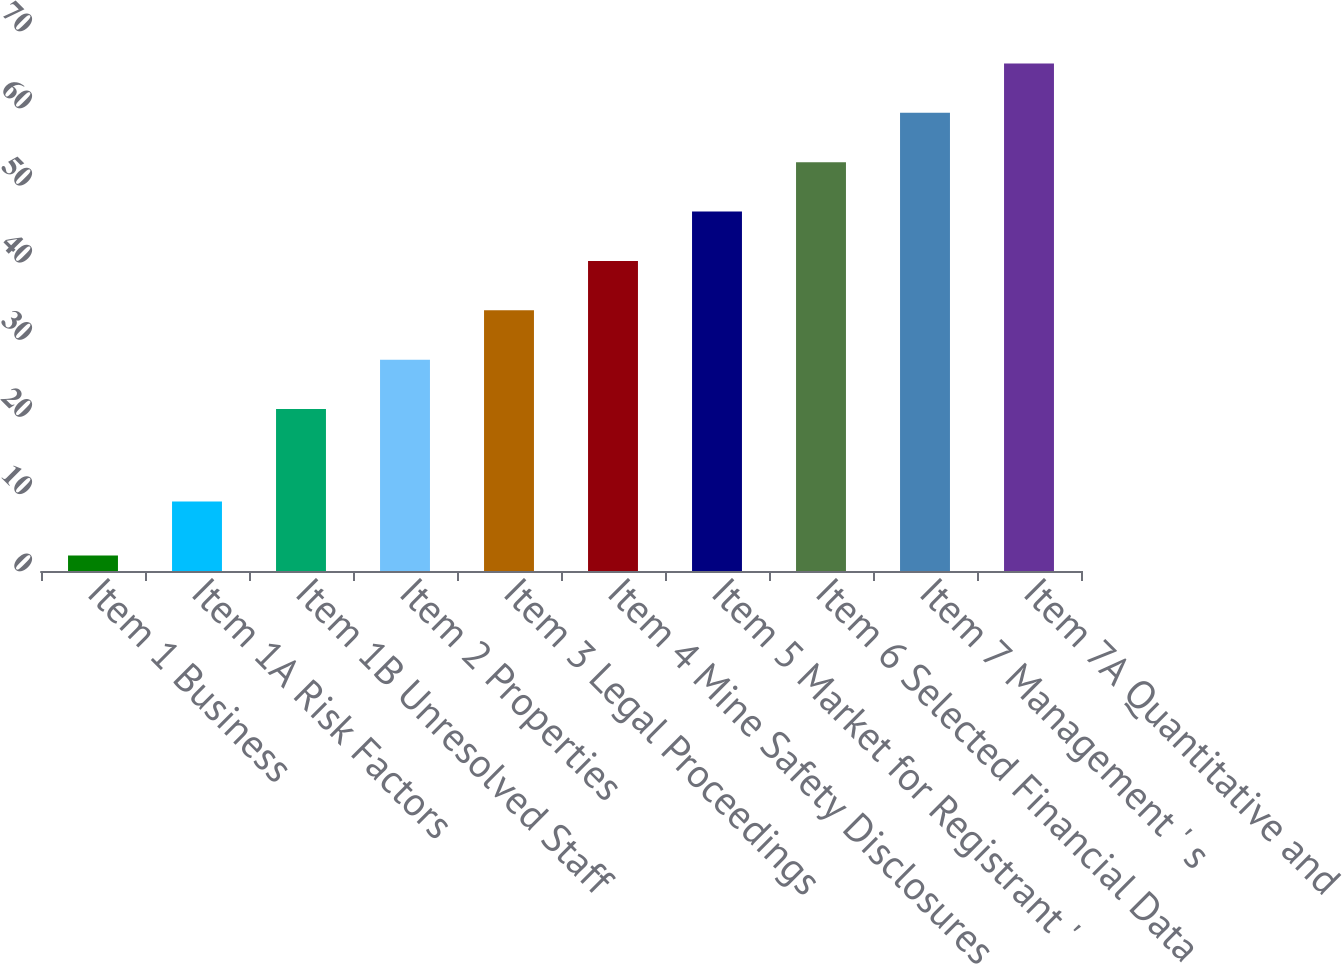Convert chart. <chart><loc_0><loc_0><loc_500><loc_500><bar_chart><fcel>Item 1 Business<fcel>Item 1A Risk Factors<fcel>Item 1B Unresolved Staff<fcel>Item 2 Properties<fcel>Item 3 Legal Proceedings<fcel>Item 4 Mine Safety Disclosures<fcel>Item 5 Market for Registrant '<fcel>Item 6 Selected Financial Data<fcel>Item 7 Management ' s<fcel>Item 7A Quantitative and<nl><fcel>2<fcel>9<fcel>21<fcel>27.4<fcel>33.8<fcel>40.2<fcel>46.6<fcel>53<fcel>59.4<fcel>65.8<nl></chart> 